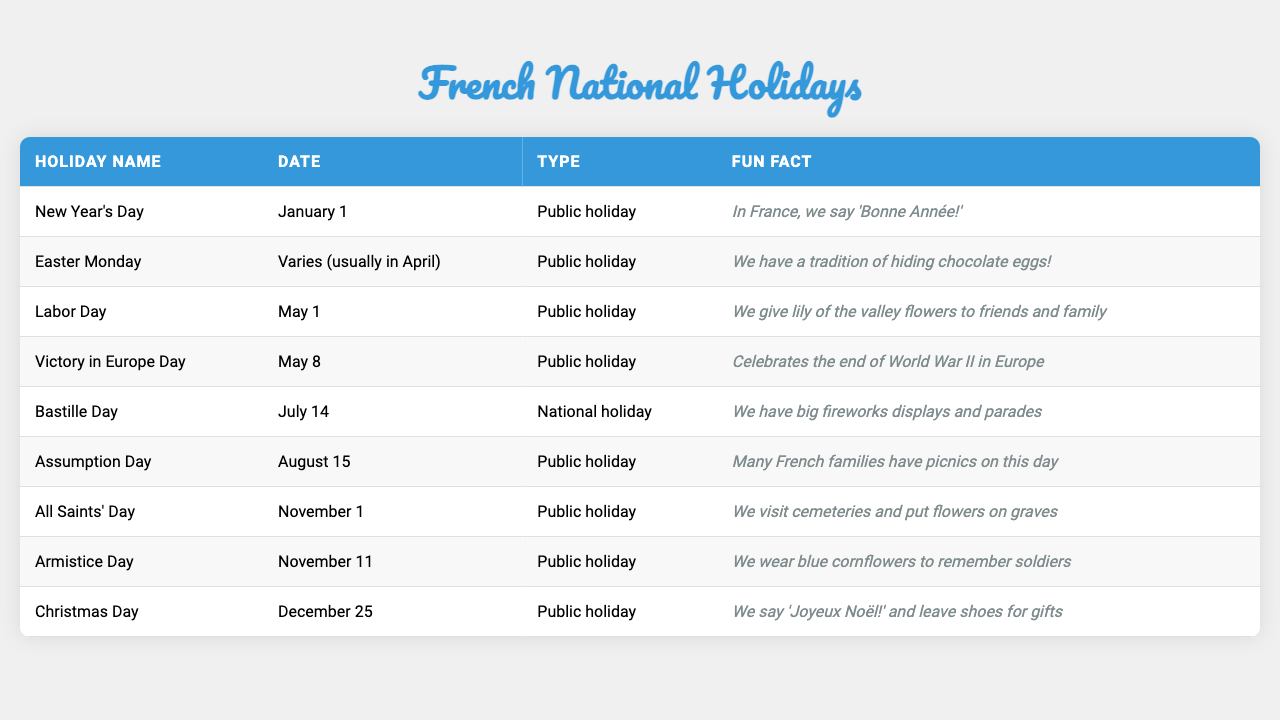What is the date of Bastille Day? According to the table, Bastille Day is celebrated on July 14.
Answer: July 14 What unique tradition is associated with Easter Monday in France? The table states that a tradition involves hiding chocolate eggs on Easter Monday.
Answer: Hiding chocolate eggs How many public holidays are listed in the table? The holidays marked as public holidays include New Year's Day, Easter Monday, Labor Day, Victory in Europe Day, Assumption Day, All Saints' Day, Armistice Day, and Christmas Day. Counting these, there are 8 public holidays.
Answer: 8 Is Labor Day celebrated on May 1? The table mentions that Labor Day occurs on May 1, confirming that this statement is true.
Answer: Yes What fun fact do we learn about All Saints' Day? The table reveals that on All Saints' Day, people visit cemeteries and place flowers on graves.
Answer: Visit cemeteries and place flowers Which holiday has a fun fact about wearing a specific flower? The fun fact about wearing blue cornflowers is associated with Armistice Day, as per the table.
Answer: Armistice Day How does the type of holiday differ between Bastille Day and New Year's Day? The table indicates that Bastille Day is a national holiday while New Year's Day is a public holiday, reflecting a distinction in status.
Answer: National holiday vs Public holiday What holiday is celebrated to mark the end of World War II in Europe? The table shows that Victory in Europe Day celebrates the end of World War II in Europe.
Answer: Victory in Europe Day Which holiday has the fun fact about leaving shoes for gifts? According to the table, Christmas Day is associated with the fun fact of leaving shoes for gifts.
Answer: Christmas Day If we look at the holidays in May, how many of them are public holidays? The table shows that there are two holidays in May: Labor Day and Victory in Europe Day, both of which are public holidays. Therefore, the total is 2.
Answer: 2 What is the common celebration associated with the Assumption Day? The table describes a tradition of having picnics on Assumption Day, which many French families enjoy.
Answer: Picnics 